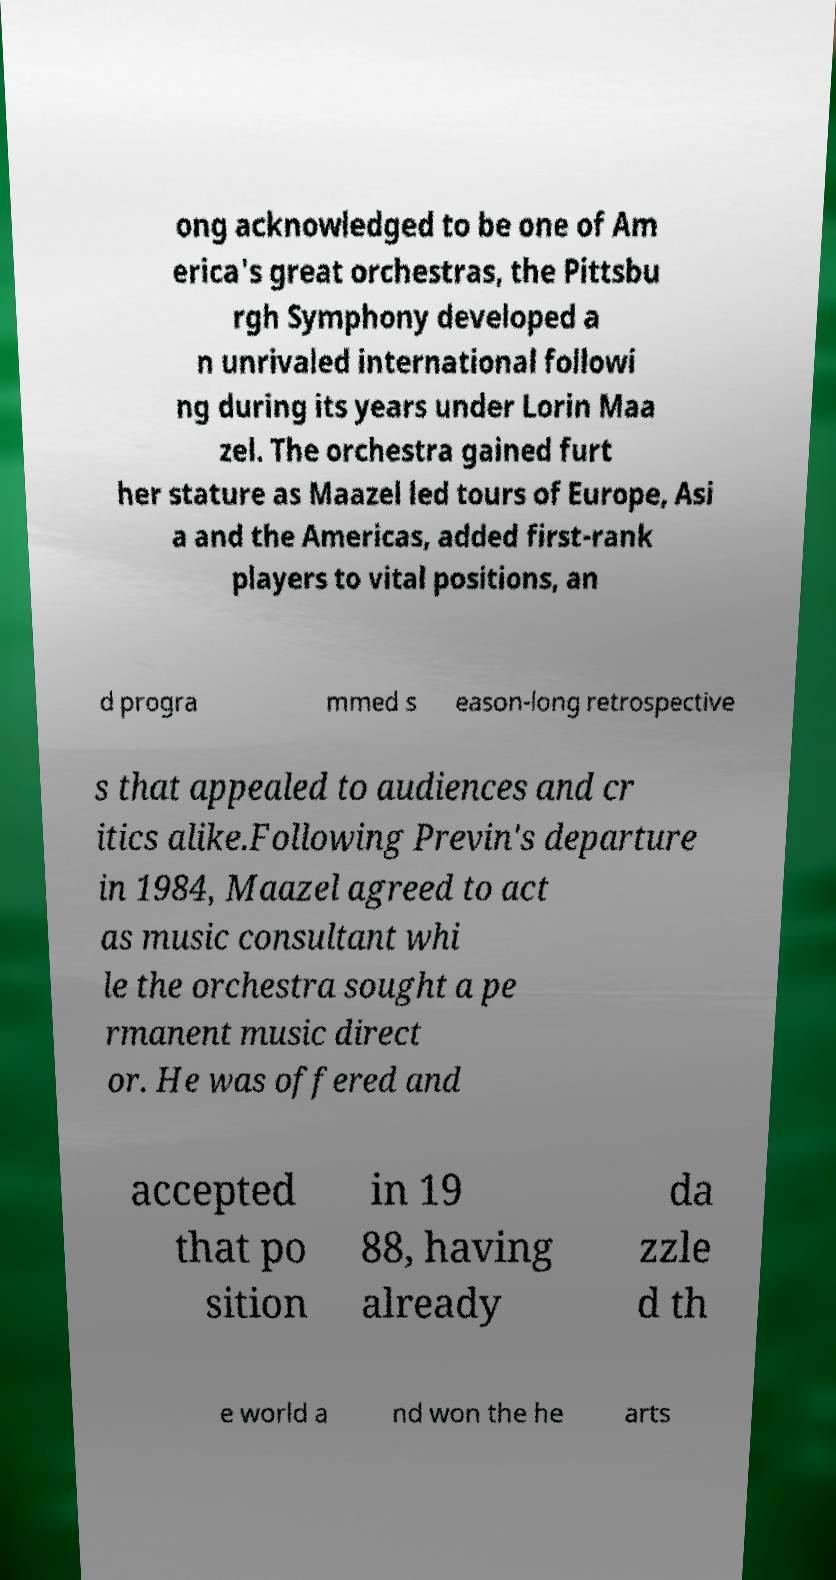What messages or text are displayed in this image? I need them in a readable, typed format. ong acknowledged to be one of Am erica's great orchestras, the Pittsbu rgh Symphony developed a n unrivaled international followi ng during its years under Lorin Maa zel. The orchestra gained furt her stature as Maazel led tours of Europe, Asi a and the Americas, added first-rank players to vital positions, an d progra mmed s eason-long retrospective s that appealed to audiences and cr itics alike.Following Previn's departure in 1984, Maazel agreed to act as music consultant whi le the orchestra sought a pe rmanent music direct or. He was offered and accepted that po sition in 19 88, having already da zzle d th e world a nd won the he arts 